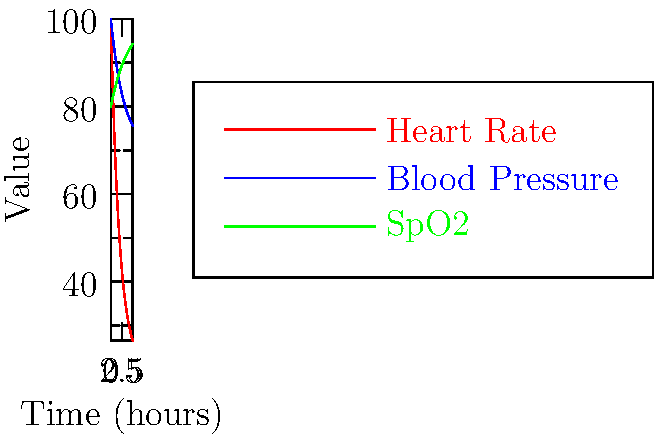Based on the vital signs chart showing heart rate, blood pressure, and SpO2 over time after anesthesia, which parameter indicates the slowest recovery to baseline and might be used to predict a longer overall recovery time? To determine which parameter indicates the slowest recovery and might predict a longer overall recovery time, we need to analyze each vital sign:

1. Heart Rate (red line):
   - Starts high (around 100 bpm) and quickly decreases
   - Stabilizes at about 2-3 hours post-anesthesia
   - Shows rapid recovery to baseline

2. Blood Pressure (blue line):
   - Starts slightly elevated and gradually decreases
   - Takes longer to stabilize compared to heart rate
   - Reaches a steady state at about 3-4 hours post-anesthesia

3. SpO2 (green line):
   - Starts low (around 80%) and slowly increases
   - Shows the slowest rate of change among all parameters
   - Does not fully stabilize within the 5-hour window shown

Comparing these trends:
- Heart rate recovers fastest
- Blood pressure takes longer but stabilizes within the timeframe
- SpO2 shows the slowest improvement and doesn't fully stabilize

Therefore, SpO2 (oxygen saturation) indicates the slowest recovery to baseline and might be used to predict a longer overall recovery time. This is particularly relevant in resource-limited settings where continuous monitoring might be challenging, and a single parameter for predicting recovery time would be valuable.
Answer: SpO2 (oxygen saturation) 